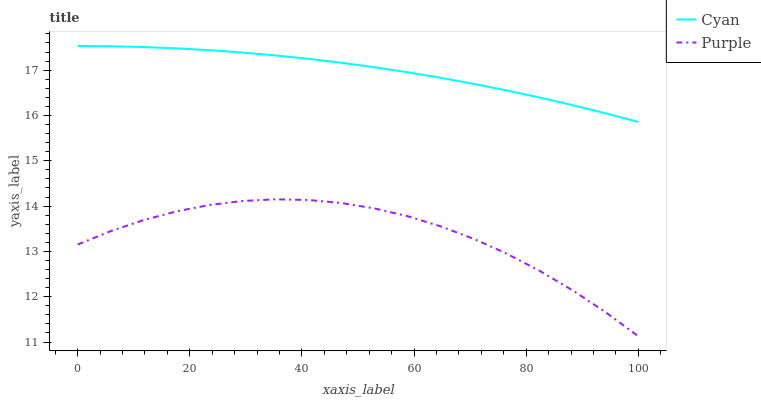Does Purple have the minimum area under the curve?
Answer yes or no. Yes. Does Cyan have the maximum area under the curve?
Answer yes or no. Yes. Does Cyan have the minimum area under the curve?
Answer yes or no. No. Is Cyan the smoothest?
Answer yes or no. Yes. Is Purple the roughest?
Answer yes or no. Yes. Is Cyan the roughest?
Answer yes or no. No. Does Cyan have the lowest value?
Answer yes or no. No. Is Purple less than Cyan?
Answer yes or no. Yes. Is Cyan greater than Purple?
Answer yes or no. Yes. Does Purple intersect Cyan?
Answer yes or no. No. 